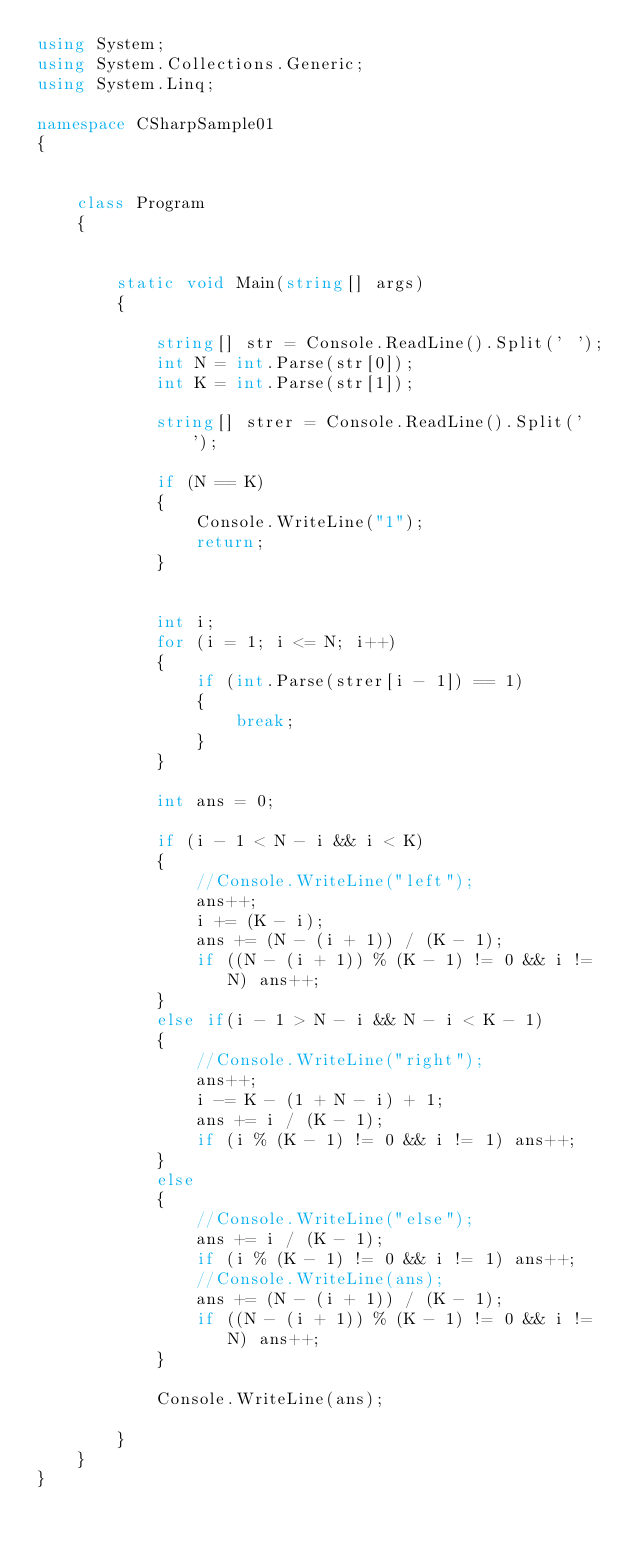Convert code to text. <code><loc_0><loc_0><loc_500><loc_500><_C#_>using System;
using System.Collections.Generic;
using System.Linq;

namespace CSharpSample01
{


    class Program
    {


        static void Main(string[] args)
        {

            string[] str = Console.ReadLine().Split(' ');
            int N = int.Parse(str[0]);
            int K = int.Parse(str[1]);

            string[] strer = Console.ReadLine().Split(' ');

            if (N == K)
            {
                Console.WriteLine("1");
                return;
            }


            int i;
            for (i = 1; i <= N; i++)
            {
                if (int.Parse(strer[i - 1]) == 1)
                {
                    break;
                }
            }

            int ans = 0;

            if (i - 1 < N - i && i < K)
            {
                //Console.WriteLine("left");
                ans++;
                i += (K - i);
                ans += (N - (i + 1)) / (K - 1);
                if ((N - (i + 1)) % (K - 1) != 0 && i != N) ans++;
            }
            else if(i - 1 > N - i && N - i < K - 1)
            {
                //Console.WriteLine("right");
                ans++;
                i -= K - (1 + N - i) + 1;
                ans += i / (K - 1);
                if (i % (K - 1) != 0 && i != 1) ans++;
            }
            else
            {
                //Console.WriteLine("else");
                ans += i / (K - 1);
                if (i % (K - 1) != 0 && i != 1) ans++;
                //Console.WriteLine(ans);
                ans += (N - (i + 1)) / (K - 1);
                if ((N - (i + 1)) % (K - 1) != 0 && i != N) ans++;
            }
            
            Console.WriteLine(ans);

        }
    }
}</code> 